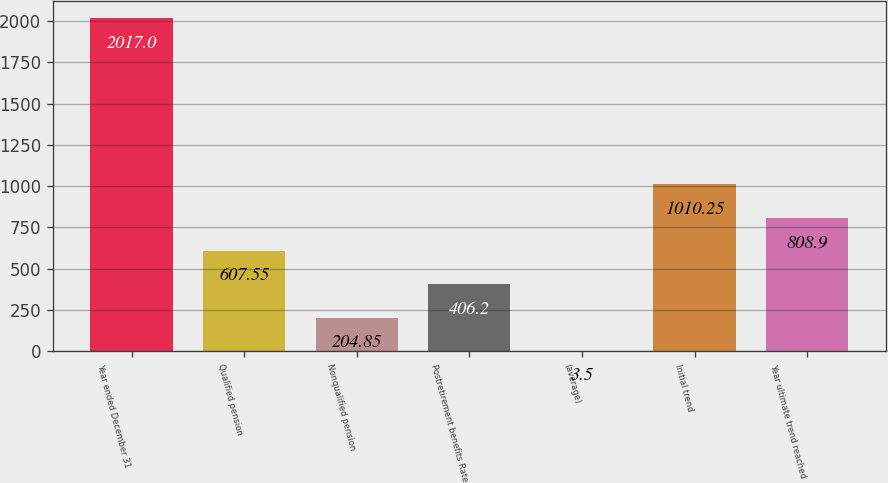Convert chart. <chart><loc_0><loc_0><loc_500><loc_500><bar_chart><fcel>Year ended December 31<fcel>Qualified pension<fcel>Nonqualified pension<fcel>Postretirement benefits Rate<fcel>(average)<fcel>Initial trend<fcel>Year ultimate trend reached<nl><fcel>2017<fcel>607.55<fcel>204.85<fcel>406.2<fcel>3.5<fcel>1010.25<fcel>808.9<nl></chart> 